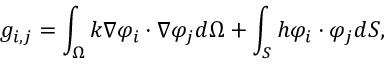<formula> <loc_0><loc_0><loc_500><loc_500>g _ { i , j } = \int _ { \Omega } k \nabla \varphi _ { i } \cdot \nabla \varphi _ { j } d \Omega + \int _ { S } h \varphi _ { i } \cdot \varphi _ { j } d S ,</formula> 